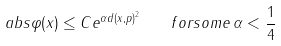Convert formula to latex. <formula><loc_0><loc_0><loc_500><loc_500>\ a b s { \varphi ( x ) } \leq C e ^ { \alpha d ( x , p ) ^ { 2 } } \quad f o r s o m e \, \alpha < \frac { 1 } { 4 }</formula> 